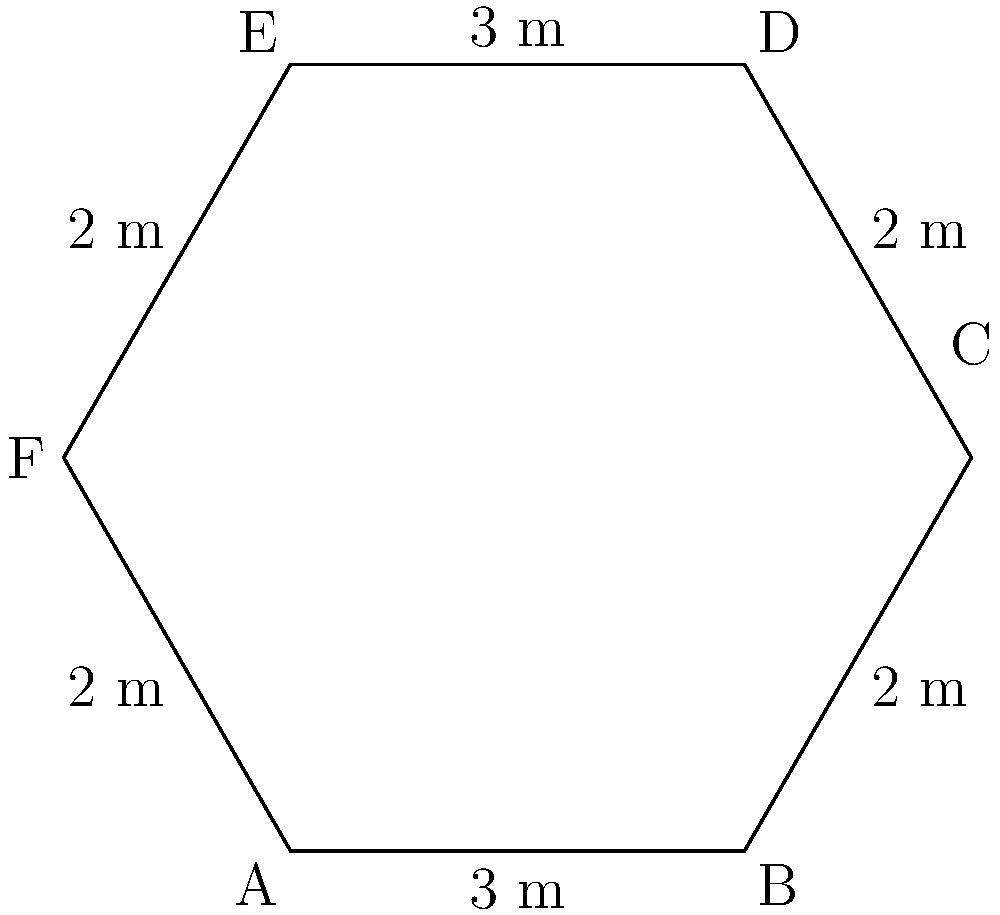A hexagonal savings vault has sides of alternating lengths: 3 meters and 2 meters, as shown in the diagram. Calculate the perimeter of the vault in meters. To calculate the perimeter of the hexagonal vault, we need to sum up the lengths of all sides. Let's break it down step-by-step:

1. Identify the lengths of the sides:
   - Sides AB and DE are 3 meters each
   - Sides BC, CD, EF, and FA are 2 meters each

2. Sum up all the sides:
   $$ \text{Perimeter} = AB + BC + CD + DE + EF + FA $$
   $$ = 3 + 2 + 2 + 3 + 2 + 2 $$

3. Perform the addition:
   $$ = 14 \text{ meters} $$

Therefore, the perimeter of the hexagonal savings vault is 14 meters.
Answer: 14 meters 